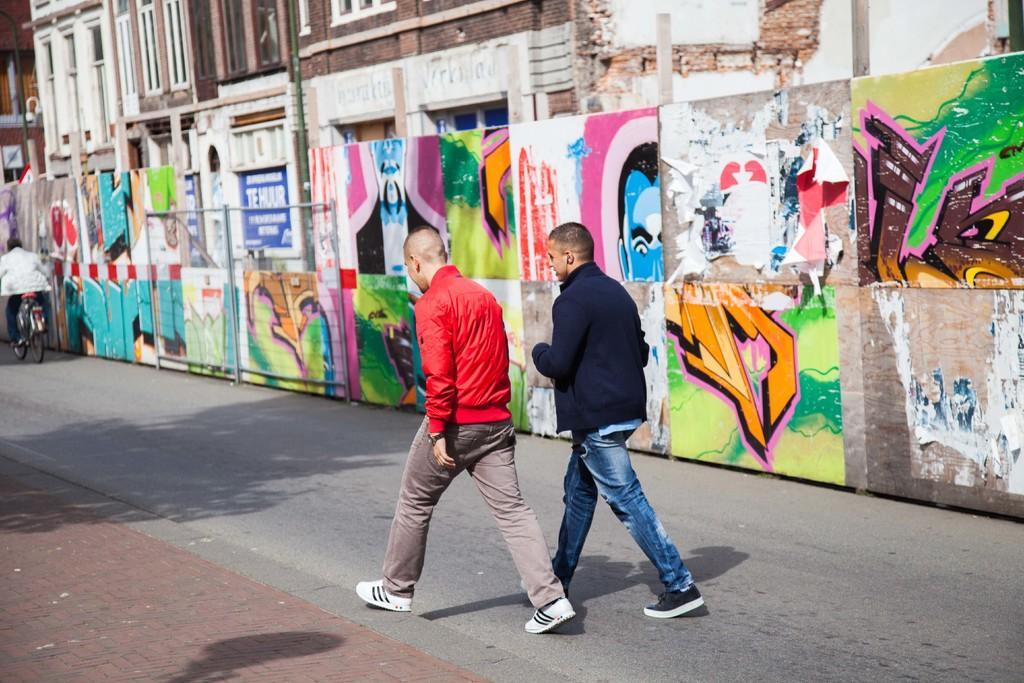What are the people in the image doing? There are two people walking on the road in the image. What is the person on the left side of the image doing? The person on the left side of the image is sitting on a bicycle. What can be seen in the background of the image? There is a wall and a building in the background of the image. What direction is the railway heading in the image? There is no railway present in the image. 